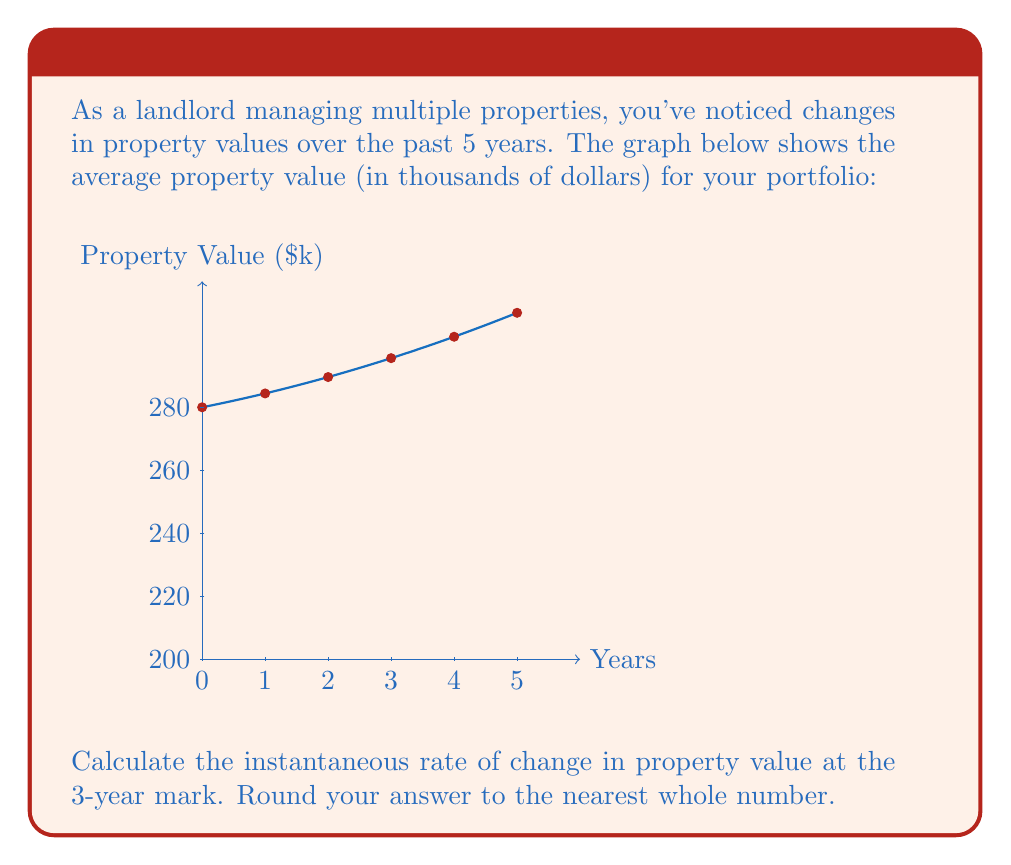Can you answer this question? To find the instantaneous rate of change at a specific point, we need to calculate the derivative of the function representing the property value and evaluate it at the given point.

1) From the graph, we can see that the function appears to be quadratic. Let's assume it has the form:

   $$f(x) = ax^2 + bx + c$$

2) We can determine the coefficients by using three points from the graph:
   At x = 0, y ≈ 200
   At x = 2, y ≈ 225
   At x = 5, y ≈ 275

3) Substituting these points into the quadratic equation:
   200 = c
   225 = 4a + 2b + 200
   275 = 25a + 5b + 200

4) Solving this system of equations:
   c = 200
   25 = 4a + 2b
   75 = 25a + 5b

5) Subtracting the second equation from the third:
   50 = 21a + 3b
   25 = 4a + 2b
   Solving these, we get: a = 0.5, b = 10

6) Therefore, our function is:
   $$f(x) = 0.5x^2 + 10x + 200$$

7) The derivative of this function is:
   $$f'(x) = x + 10$$

8) At the 3-year mark, x = 3, so:
   $$f'(3) = 3 + 10 = 13$$

9) This means the instantaneous rate of change at the 3-year mark is 13 thousand dollars per year.
Answer: 13 